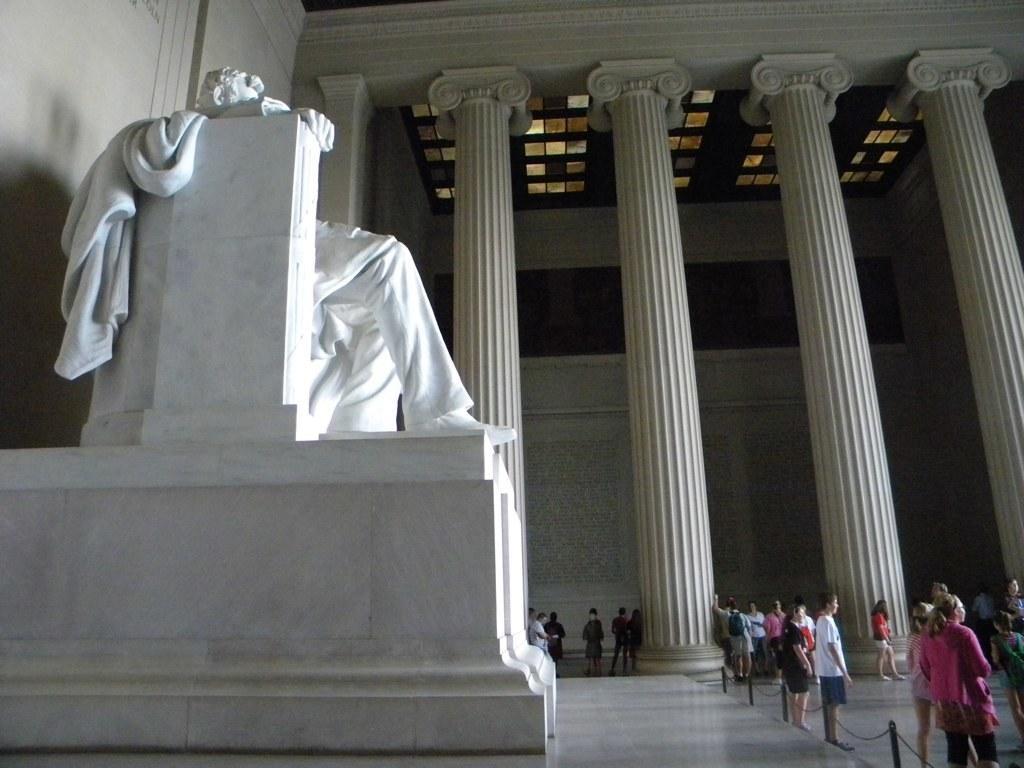Describe this image in one or two sentences. In this image I can see few persons standing, in front I can see a statue in white color. Background I can see few pillars and the wall in white color. 